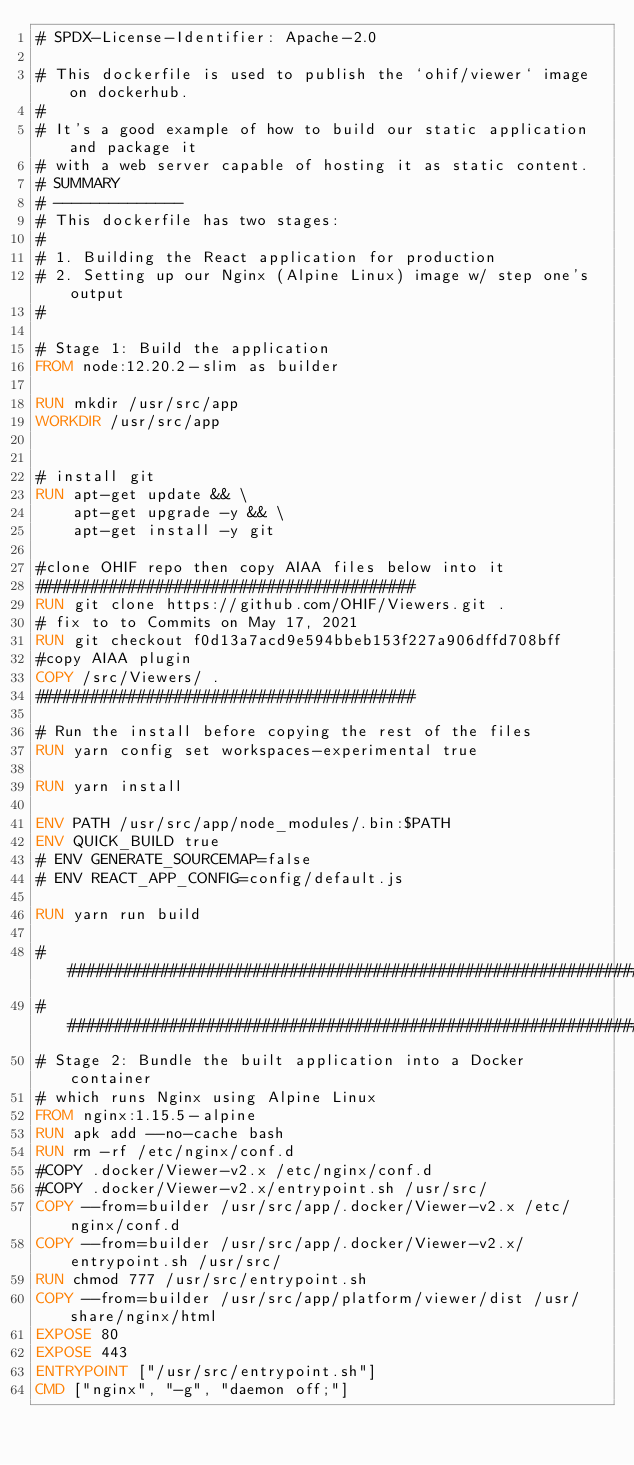<code> <loc_0><loc_0><loc_500><loc_500><_Dockerfile_># SPDX-License-Identifier: Apache-2.0

# This dockerfile is used to publish the `ohif/viewer` image on dockerhub.
#
# It's a good example of how to build our static application and package it
# with a web server capable of hosting it as static content.
# SUMMARY
# --------------
# This dockerfile has two stages:
#
# 1. Building the React application for production
# 2. Setting up our Nginx (Alpine Linux) image w/ step one's output
#

# Stage 1: Build the application
FROM node:12.20.2-slim as builder

RUN mkdir /usr/src/app
WORKDIR /usr/src/app


# install git
RUN apt-get update && \
    apt-get upgrade -y && \
    apt-get install -y git

#clone OHIF repo then copy AIAA files below into it
#########################################
RUN git clone https://github.com/OHIF/Viewers.git .
# fix to to Commits on May 17, 2021
RUN git checkout f0d13a7acd9e594bbeb153f227a906dffd708bff
#copy AIAA plugin
COPY /src/Viewers/ .
#########################################

# Run the install before copying the rest of the files
RUN yarn config set workspaces-experimental true

RUN yarn install

ENV PATH /usr/src/app/node_modules/.bin:$PATH
ENV QUICK_BUILD true
# ENV GENERATE_SOURCEMAP=false
# ENV REACT_APP_CONFIG=config/default.js

RUN yarn run build

###########################################################################################
###########################################################################################
# Stage 2: Bundle the built application into a Docker container
# which runs Nginx using Alpine Linux
FROM nginx:1.15.5-alpine
RUN apk add --no-cache bash
RUN rm -rf /etc/nginx/conf.d
#COPY .docker/Viewer-v2.x /etc/nginx/conf.d
#COPY .docker/Viewer-v2.x/entrypoint.sh /usr/src/
COPY --from=builder /usr/src/app/.docker/Viewer-v2.x /etc/nginx/conf.d
COPY --from=builder /usr/src/app/.docker/Viewer-v2.x/entrypoint.sh /usr/src/
RUN chmod 777 /usr/src/entrypoint.sh
COPY --from=builder /usr/src/app/platform/viewer/dist /usr/share/nginx/html
EXPOSE 80
EXPOSE 443
ENTRYPOINT ["/usr/src/entrypoint.sh"]
CMD ["nginx", "-g", "daemon off;"]
</code> 